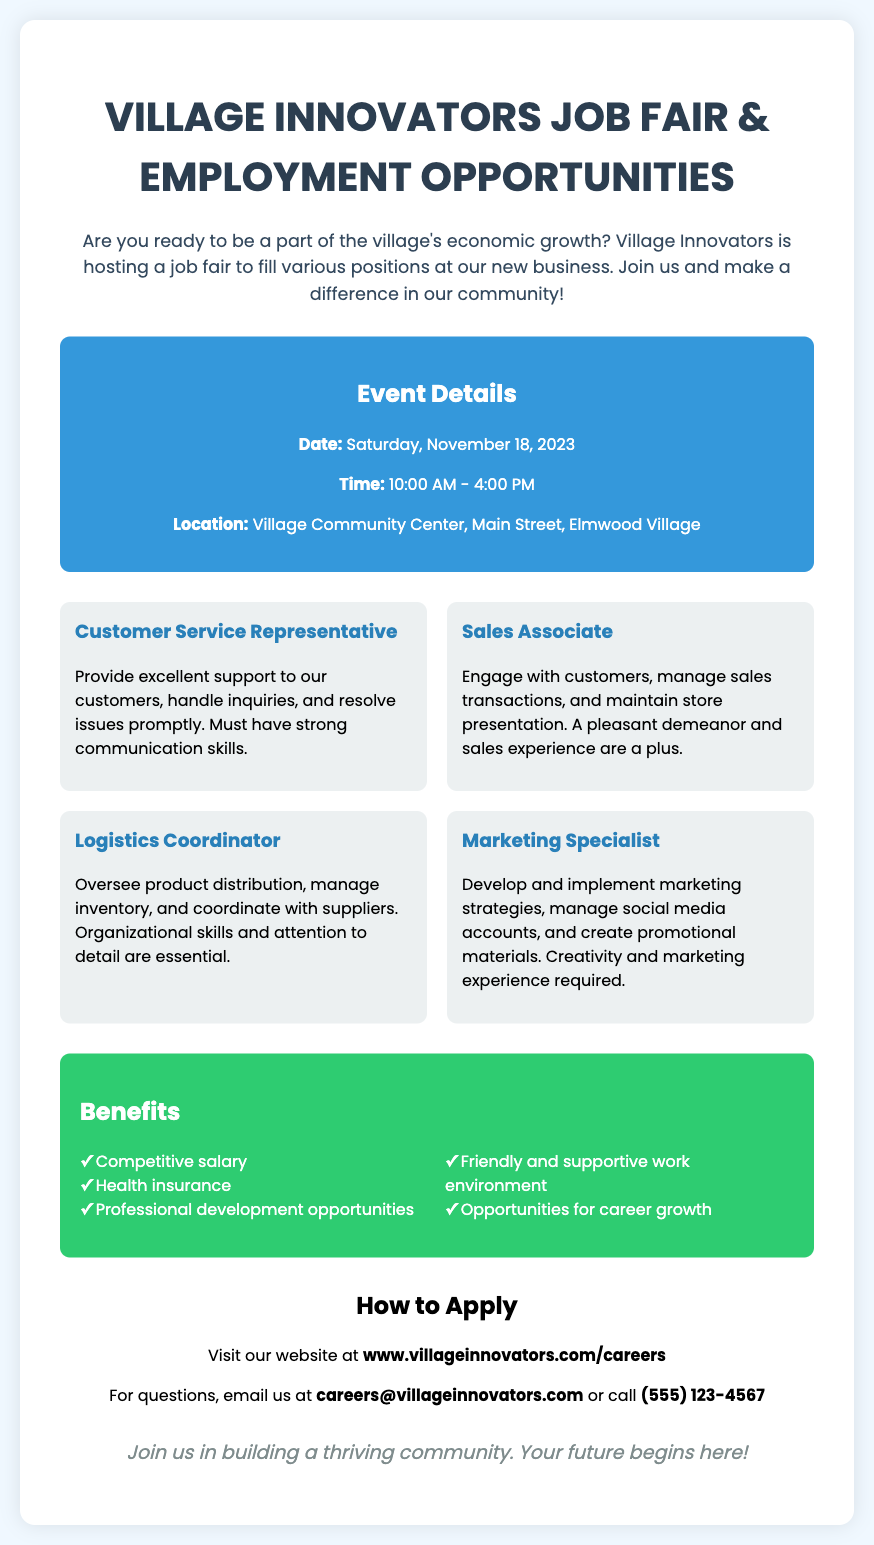What is the event date? The event date is explicitly stated in the document under the event details section.
Answer: Saturday, November 18, 2023 What position requires strong communication skills? The job description for the Customer Service Representative mentions the need for strong communication skills.
Answer: Customer Service Representative How long will the job fair last? The duration of the job fair is derived from the start and end times provided in the event details.
Answer: 6 hours What is the location of the job fair? The location is clearly listed in the event details section.
Answer: Village Community Center, Main Street, Elmwood Village List one benefit mentioned in the poster. The benefits section lists several advantages for employees, from competitive salary to opportunities for career growth.
Answer: Competitive salary What role is responsible for developing marketing strategies? The document provides a clear job title that aligns with developing marketing strategies.
Answer: Marketing Specialist What time does the job fair start? The start time of the event is specified in the event details section of the poster.
Answer: 10:00 AM What is the website for application details? The application details section includes the URL for their career website.
Answer: www.villageinnovators.com/careers 